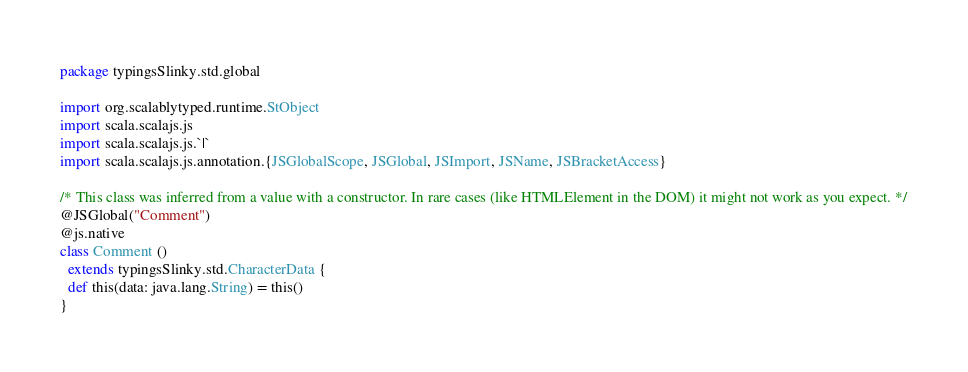Convert code to text. <code><loc_0><loc_0><loc_500><loc_500><_Scala_>package typingsSlinky.std.global

import org.scalablytyped.runtime.StObject
import scala.scalajs.js
import scala.scalajs.js.`|`
import scala.scalajs.js.annotation.{JSGlobalScope, JSGlobal, JSImport, JSName, JSBracketAccess}

/* This class was inferred from a value with a constructor. In rare cases (like HTMLElement in the DOM) it might not work as you expect. */
@JSGlobal("Comment")
@js.native
class Comment ()
  extends typingsSlinky.std.CharacterData {
  def this(data: java.lang.String) = this()
}
</code> 